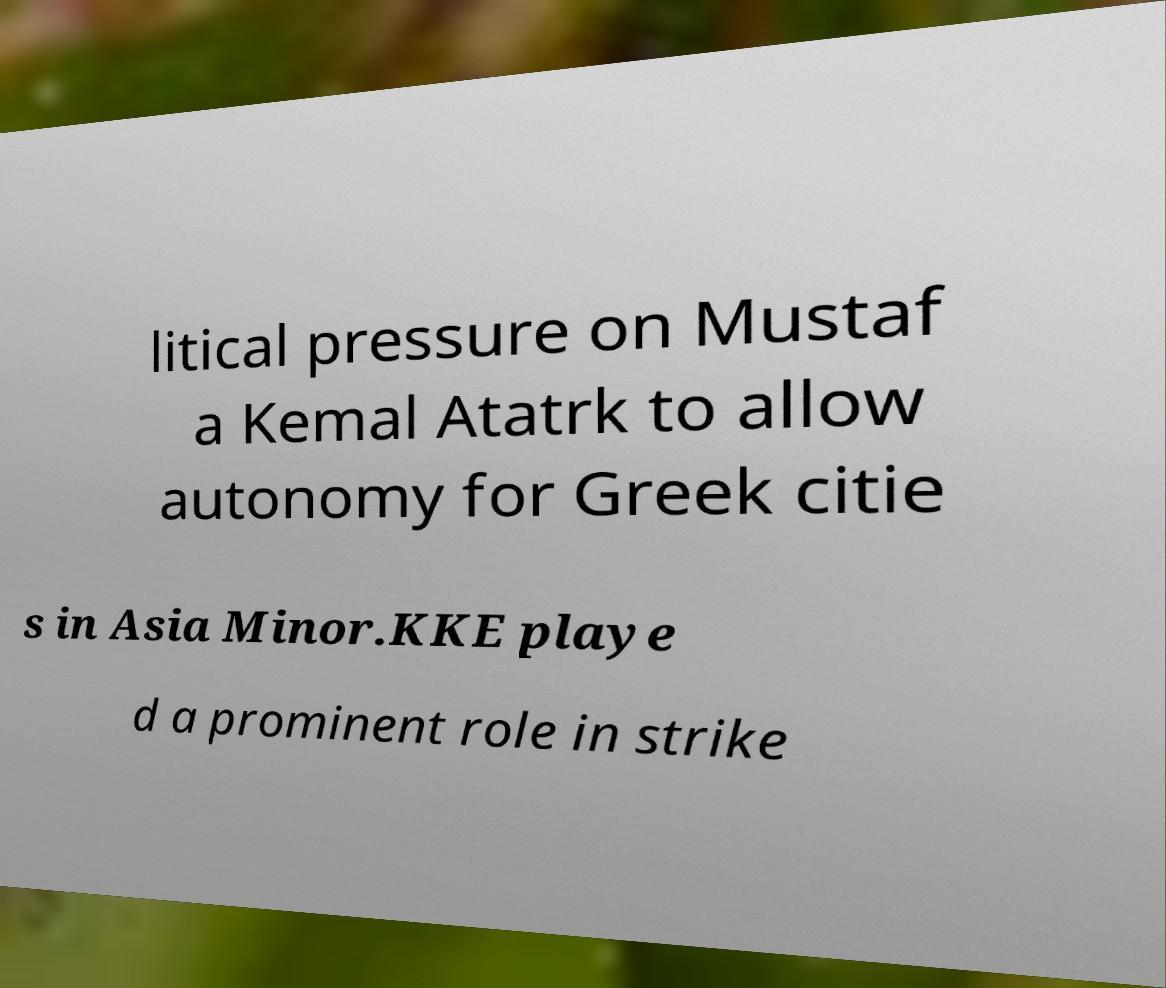Can you read and provide the text displayed in the image?This photo seems to have some interesting text. Can you extract and type it out for me? litical pressure on Mustaf a Kemal Atatrk to allow autonomy for Greek citie s in Asia Minor.KKE playe d a prominent role in strike 